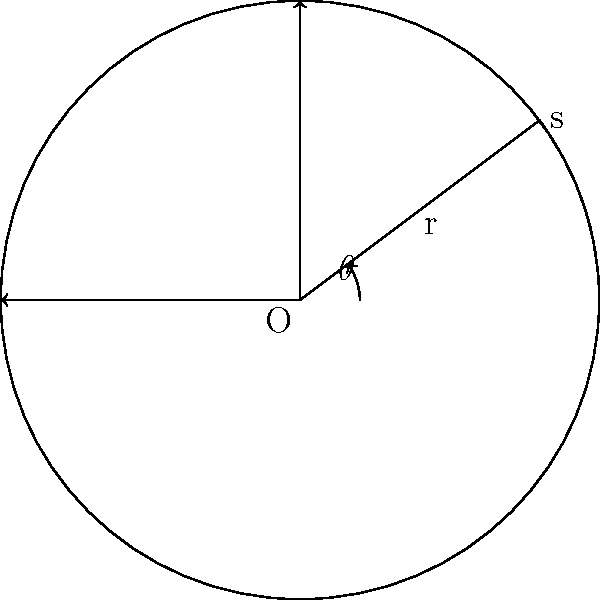As an expert in sundial design, you are working on a circular sundial with a radius of 10 meters. The gnomon casts a shadow that sweeps out a sector with a central angle of 36.87°. Calculate the area of this sector to the nearest square meter, considering the precision required in your field of excavation and discovery. To solve this problem, we'll follow these steps:

1) The formula for the area of a sector is:

   $$A = \frac{1}{2}r^2\theta$$

   where $A$ is the area, $r$ is the radius, and $\theta$ is the central angle in radians.

2) We're given the angle in degrees (36.87°), so we need to convert it to radians:

   $$\theta = 36.87° \times \frac{\pi}{180°} = 0.6435 \text{ radians}$$

3) Now we can substitute the values into our formula:

   $$A = \frac{1}{2} \times 10^2 \times 0.6435$$

4) Simplify:

   $$A = 50 \times 0.6435 = 32.175 \text{ m}^2$$

5) Rounding to the nearest square meter:

   $$A \approx 32 \text{ m}^2$$

As an expert in the field, this level of precision is suitable for most sundial designs and archaeological interpretations.
Answer: 32 m² 